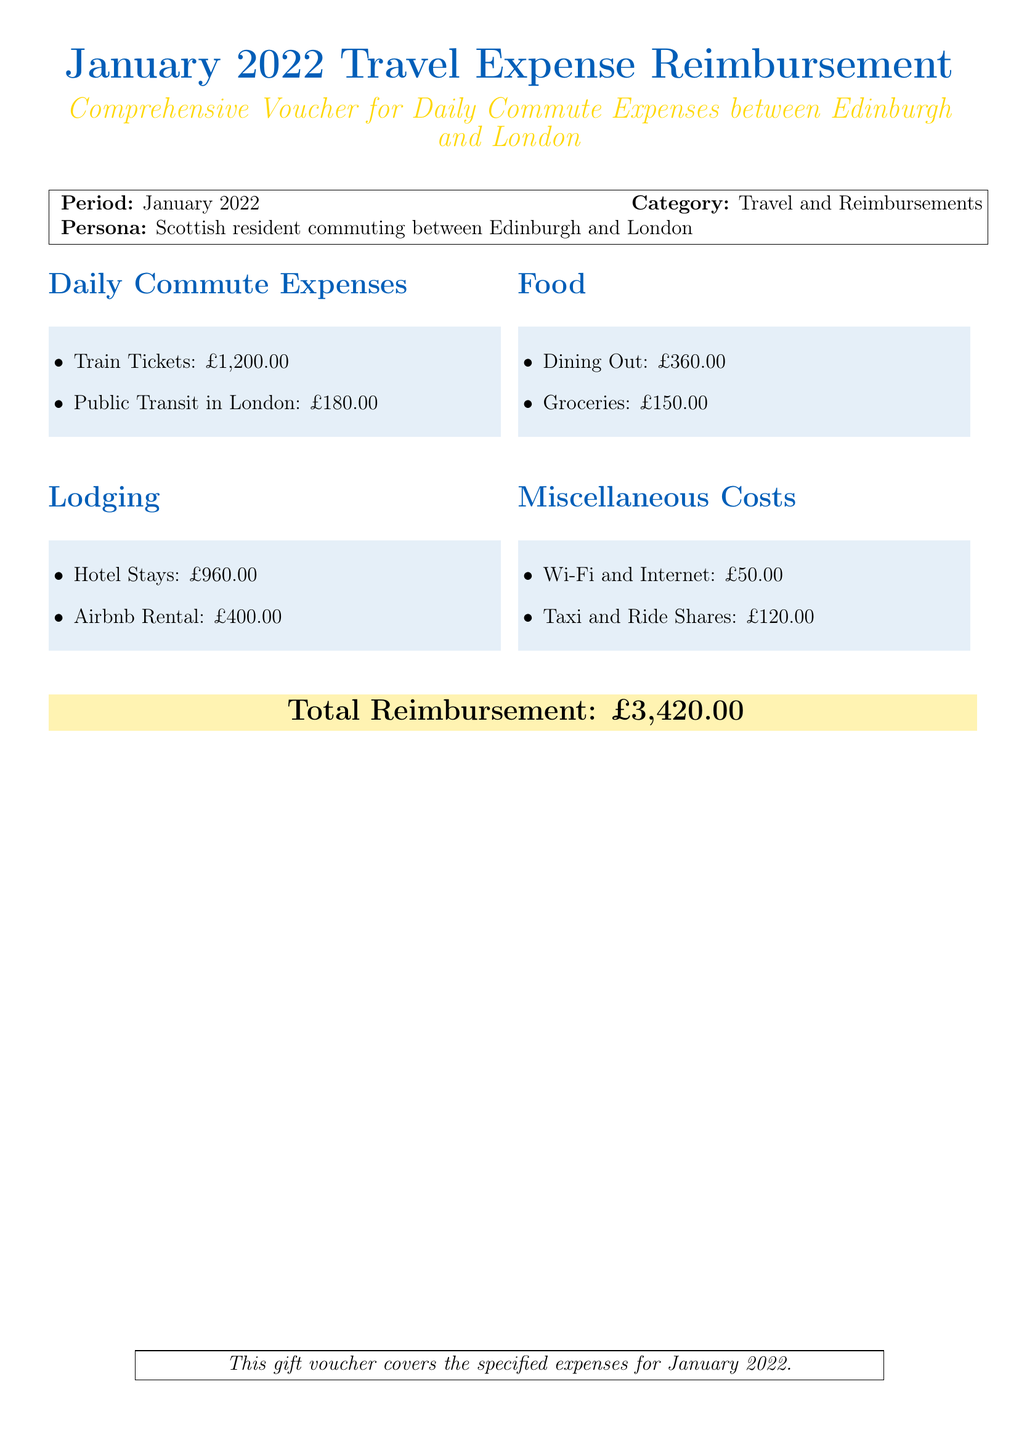what is the total reimbursement amount? The total reimbursement is stated at the bottom of the document, which sums all the expenses listed.
Answer: £3,420.00 how much were the train tickets? The document specifies the amount spent on train tickets in the daily commute expenses section.
Answer: £1,200.00 which category has the highest expense in the document? By comparing each category's total expenses, lodging has the highest amount detailed in the document.
Answer: Lodging how much did the person spend on food? The food expenses are detailed in the document, indicating the total costs for dining out and groceries.
Answer: £510.00 what was the cost of Airbnb rental? The document specifies the individual cost of the Airbnb rental under the lodging section.
Answer: £400.00 how many categories of expenses are listed in the document? The expenses are divided into four distinct categories in the document.
Answer: Four what dates does this reimbursement cover? The period specified for the reimbursement is stated at the beginning of the document.
Answer: January 2022 how much was spent on miscellaneous costs? The document provides a total for miscellaneous costs, which includes various smaller expenses.
Answer: £170.00 what is the persona mentioned in the document? The document describes the persona associated with the expenses as a resident commuting between two specific cities.
Answer: Scottish resident commuting between Edinburgh and London 